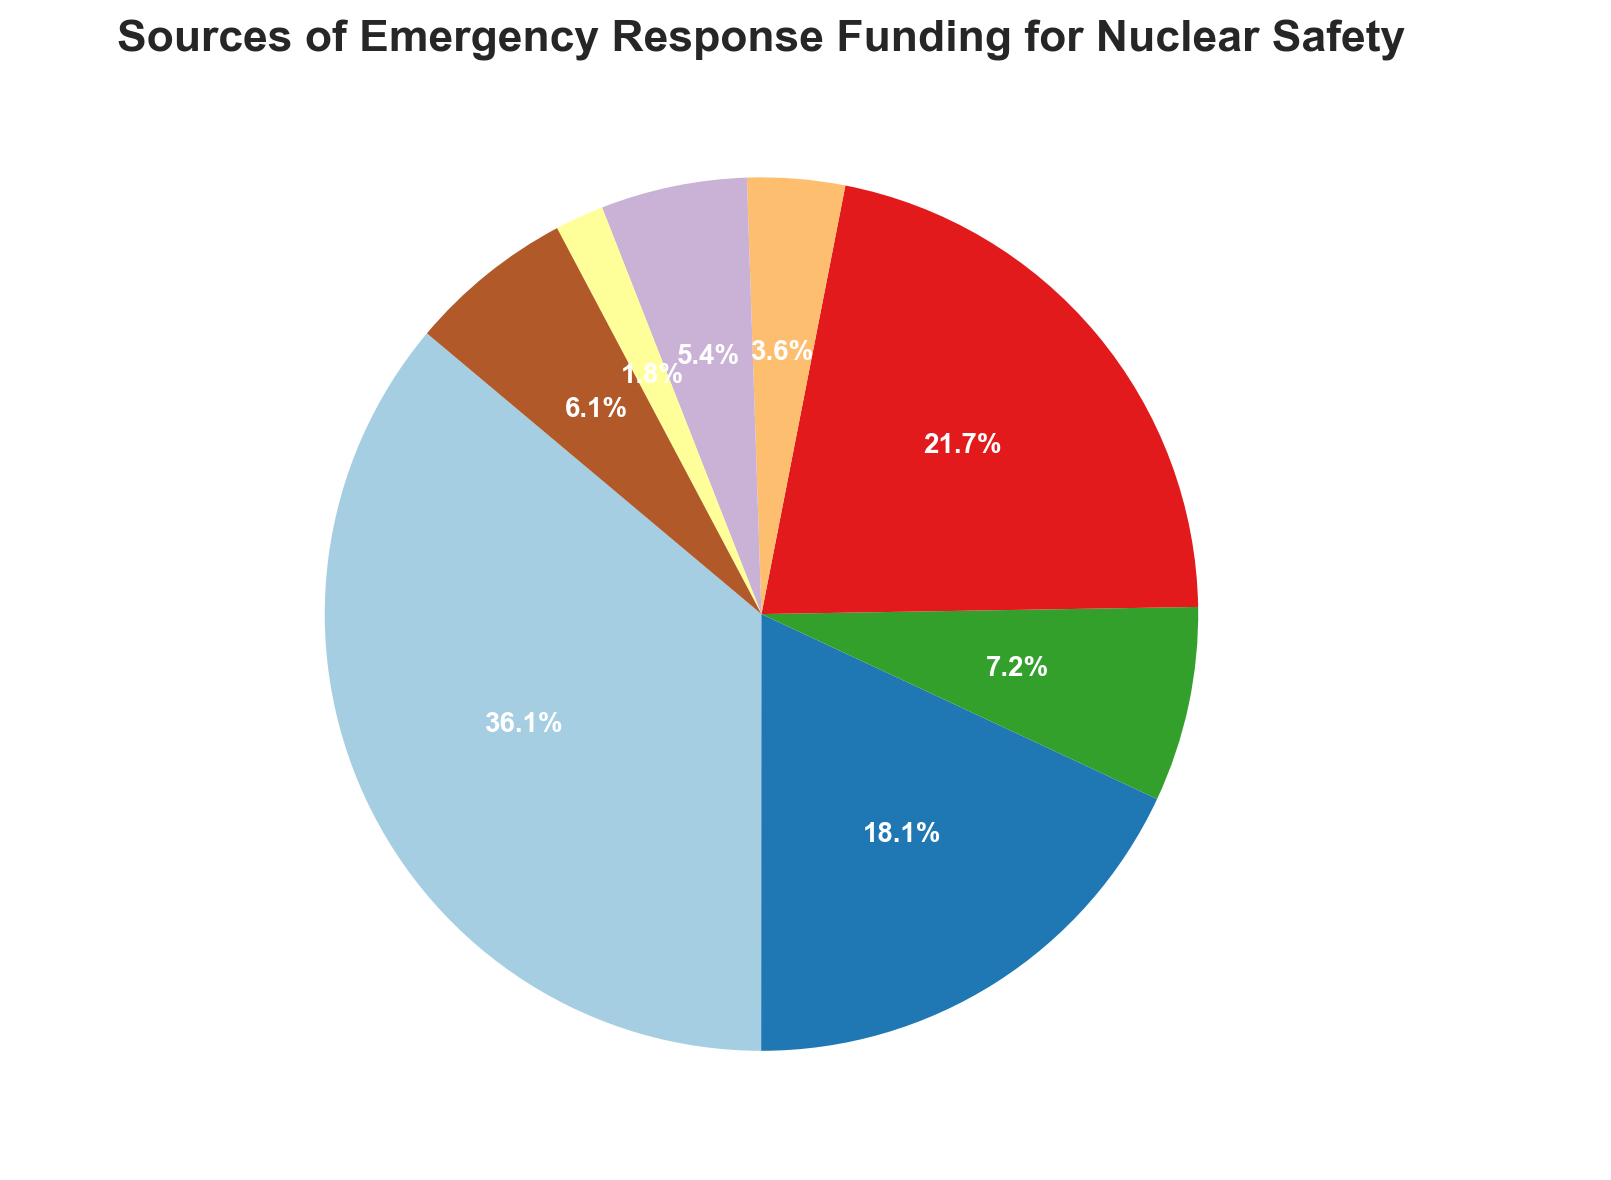What is the percentage of funding from the Federal Government? The Federal Government's funding amount is labeled as 5000000 and appears as 40.0% on the pie chart.
Answer: 40.0% Which source contributes the least amount of funding? Public Donations are labeled with the smallest wedge on the pie chart, indicated as 250000, making up the smallest percentage, which is 2.0%.
Answer: Public Donations Is the funding from Nuclear Power Plant Operators greater than that from State Government? The funding amount for Nuclear Power Plant Operators is 3000000, and the funding amount for the State Government is 2500000. Since 3000000 is greater than 2500000, the former is higher.
Answer: Yes What is the combined percentage of funding from Non-Governmental Organizations, International Aid, and Public Donations? Non-Governmental Organizations contribute 4.0%, International Aid contributes 6.0%, and Public Donations contribute 2.0%. Adding these percentages together gives 4.0% + 6.0% + 2.0% = 12.0%.
Answer: 12.0% How does the amount of funding from the Private Sector Partnerships compare to that from the Local Government? The pie chart shows Private Sector Partnerships provide 850000 while the Local Government's funding is 1000000. Since 850000 is less than 1000000, the Private Sector Partnerships contribute less.
Answer: Less What percentage of the total funding comes from the Federal and State Governments combined? The Federal Government contributes 40.0% and the State Government contributes 20.0%. Adding these percentages results in 40.0% + 20.0% = 60.0%.
Answer: 60.0% Which funding source has the third-largest wedge in the pie chart? The largest wedge is from the Federal Government (40.0%), followed by Nuclear Power Plant Operators (24.0%), and then the State Government (20.0%) which is the third largest.
Answer: State Government If Public Donations doubled their funding amount, what would their new percentage be? The current funding amount from Public Donations is 250000. If it doubled, it would be 500000. The total funding amount currently is 12500000. Adding the extra 250000 for the doubled donations gives 12750000. The new percentage for Public Donations would be (500000/12750000) * 100 = 3.9%.
Answer: 3.9% 